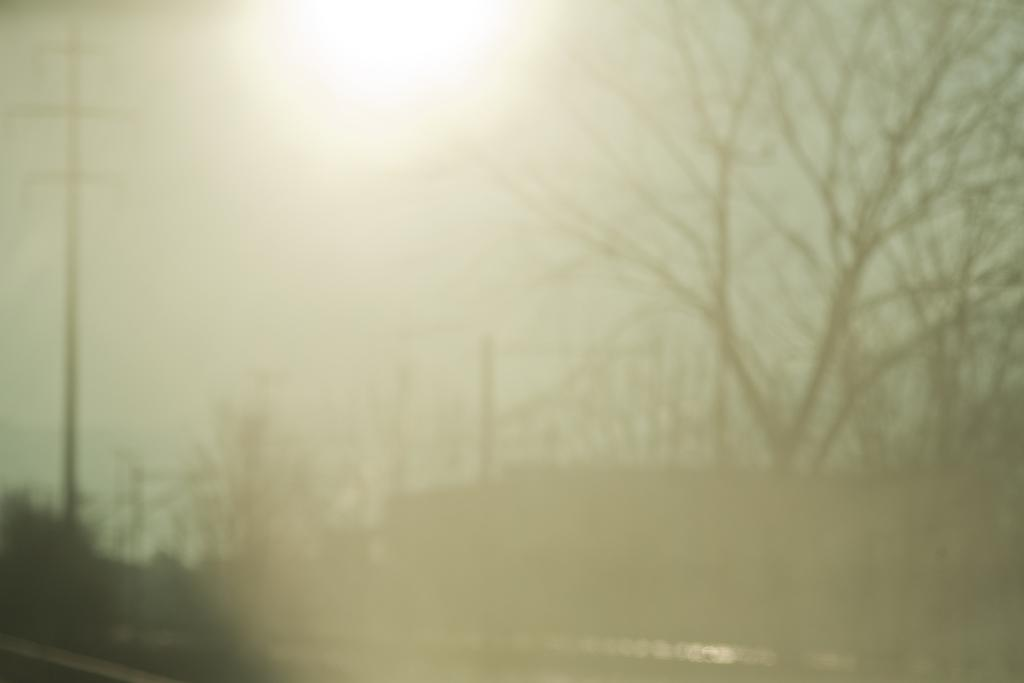What type of vegetation can be seen in the image? There are trees in the image. What part of the natural environment is visible in the image? The sky is visible in the image. What type of toe can be seen in the image? There are no toes present in the image; it features trees and the sky. What type of business is being conducted in the image? There is no business activity depicted in the image; it features trees and the sky. 